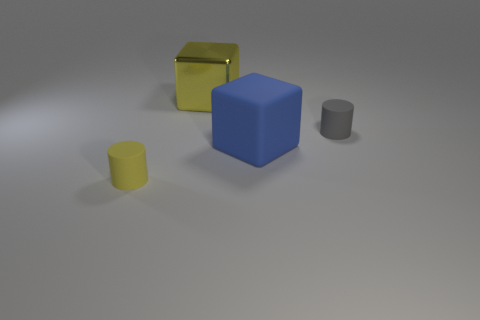Add 4 tiny brown metal objects. How many objects exist? 8 Subtract 0 green balls. How many objects are left? 4 Subtract all large gray things. Subtract all big blue cubes. How many objects are left? 3 Add 1 big blue blocks. How many big blue blocks are left? 2 Add 1 gray rubber cylinders. How many gray rubber cylinders exist? 2 